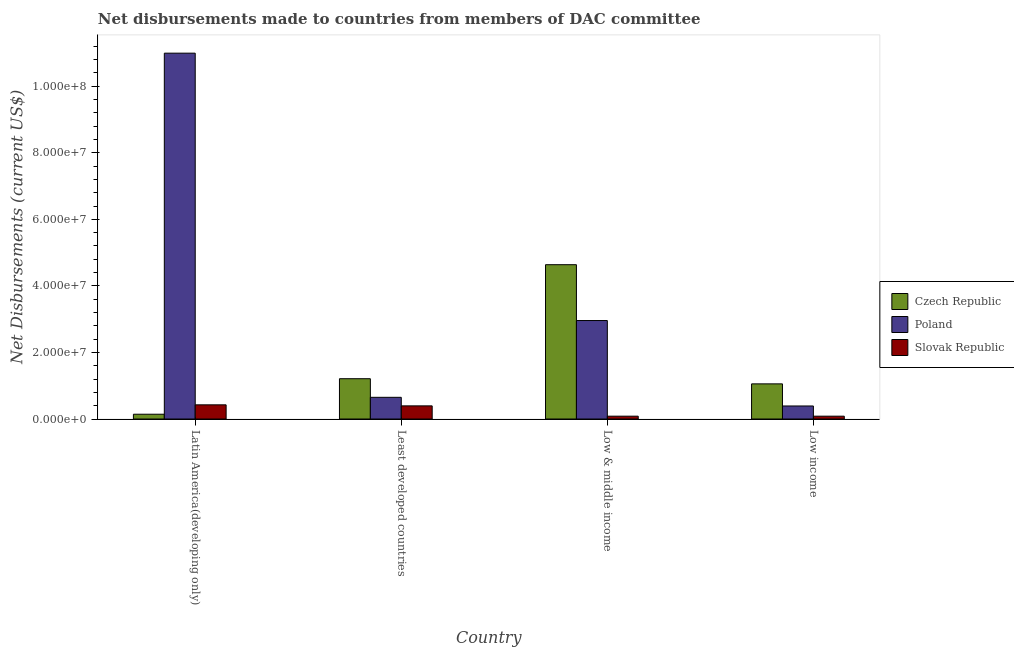How many different coloured bars are there?
Your answer should be very brief. 3. Are the number of bars per tick equal to the number of legend labels?
Your answer should be very brief. Yes. Are the number of bars on each tick of the X-axis equal?
Your answer should be compact. Yes. How many bars are there on the 3rd tick from the right?
Your answer should be very brief. 3. What is the label of the 2nd group of bars from the left?
Your answer should be very brief. Least developed countries. In how many cases, is the number of bars for a given country not equal to the number of legend labels?
Make the answer very short. 0. What is the net disbursements made by slovak republic in Least developed countries?
Keep it short and to the point. 3.95e+06. Across all countries, what is the maximum net disbursements made by czech republic?
Your answer should be compact. 4.64e+07. Across all countries, what is the minimum net disbursements made by slovak republic?
Make the answer very short. 8.50e+05. In which country was the net disbursements made by slovak republic maximum?
Make the answer very short. Latin America(developing only). In which country was the net disbursements made by czech republic minimum?
Make the answer very short. Latin America(developing only). What is the total net disbursements made by czech republic in the graph?
Your answer should be very brief. 7.05e+07. What is the difference between the net disbursements made by poland in Low & middle income and that in Low income?
Ensure brevity in your answer.  2.57e+07. What is the difference between the net disbursements made by slovak republic in Latin America(developing only) and the net disbursements made by poland in Low & middle income?
Your answer should be very brief. -2.53e+07. What is the average net disbursements made by poland per country?
Provide a short and direct response. 3.75e+07. What is the difference between the net disbursements made by slovak republic and net disbursements made by poland in Latin America(developing only)?
Your answer should be compact. -1.06e+08. In how many countries, is the net disbursements made by czech republic greater than 76000000 US$?
Ensure brevity in your answer.  0. What is the ratio of the net disbursements made by poland in Latin America(developing only) to that in Low income?
Your response must be concise. 28.04. Is the difference between the net disbursements made by poland in Latin America(developing only) and Least developed countries greater than the difference between the net disbursements made by slovak republic in Latin America(developing only) and Least developed countries?
Make the answer very short. Yes. What is the difference between the highest and the lowest net disbursements made by slovak republic?
Make the answer very short. 3.41e+06. In how many countries, is the net disbursements made by slovak republic greater than the average net disbursements made by slovak republic taken over all countries?
Your answer should be very brief. 2. What does the 1st bar from the left in Least developed countries represents?
Provide a short and direct response. Czech Republic. What does the 3rd bar from the right in Low income represents?
Your answer should be compact. Czech Republic. Is it the case that in every country, the sum of the net disbursements made by czech republic and net disbursements made by poland is greater than the net disbursements made by slovak republic?
Your answer should be compact. Yes. How many bars are there?
Your answer should be compact. 12. How many countries are there in the graph?
Keep it short and to the point. 4. What is the difference between two consecutive major ticks on the Y-axis?
Your answer should be compact. 2.00e+07. Are the values on the major ticks of Y-axis written in scientific E-notation?
Offer a very short reply. Yes. Where does the legend appear in the graph?
Ensure brevity in your answer.  Center right. How many legend labels are there?
Offer a terse response. 3. How are the legend labels stacked?
Make the answer very short. Vertical. What is the title of the graph?
Keep it short and to the point. Net disbursements made to countries from members of DAC committee. Does "Unemployment benefits" appear as one of the legend labels in the graph?
Ensure brevity in your answer.  No. What is the label or title of the Y-axis?
Provide a short and direct response. Net Disbursements (current US$). What is the Net Disbursements (current US$) of Czech Republic in Latin America(developing only)?
Provide a succinct answer. 1.44e+06. What is the Net Disbursements (current US$) in Poland in Latin America(developing only)?
Your answer should be very brief. 1.10e+08. What is the Net Disbursements (current US$) of Slovak Republic in Latin America(developing only)?
Your answer should be very brief. 4.26e+06. What is the Net Disbursements (current US$) of Czech Republic in Least developed countries?
Provide a succinct answer. 1.21e+07. What is the Net Disbursements (current US$) in Poland in Least developed countries?
Provide a succinct answer. 6.52e+06. What is the Net Disbursements (current US$) in Slovak Republic in Least developed countries?
Offer a very short reply. 3.95e+06. What is the Net Disbursements (current US$) of Czech Republic in Low & middle income?
Ensure brevity in your answer.  4.64e+07. What is the Net Disbursements (current US$) in Poland in Low & middle income?
Provide a short and direct response. 2.96e+07. What is the Net Disbursements (current US$) of Slovak Republic in Low & middle income?
Provide a short and direct response. 8.50e+05. What is the Net Disbursements (current US$) in Czech Republic in Low income?
Offer a terse response. 1.06e+07. What is the Net Disbursements (current US$) of Poland in Low income?
Your answer should be very brief. 3.92e+06. What is the Net Disbursements (current US$) in Slovak Republic in Low income?
Offer a terse response. 8.50e+05. Across all countries, what is the maximum Net Disbursements (current US$) of Czech Republic?
Provide a short and direct response. 4.64e+07. Across all countries, what is the maximum Net Disbursements (current US$) of Poland?
Provide a short and direct response. 1.10e+08. Across all countries, what is the maximum Net Disbursements (current US$) in Slovak Republic?
Give a very brief answer. 4.26e+06. Across all countries, what is the minimum Net Disbursements (current US$) of Czech Republic?
Keep it short and to the point. 1.44e+06. Across all countries, what is the minimum Net Disbursements (current US$) of Poland?
Offer a terse response. 3.92e+06. Across all countries, what is the minimum Net Disbursements (current US$) of Slovak Republic?
Your answer should be compact. 8.50e+05. What is the total Net Disbursements (current US$) in Czech Republic in the graph?
Offer a terse response. 7.05e+07. What is the total Net Disbursements (current US$) in Poland in the graph?
Give a very brief answer. 1.50e+08. What is the total Net Disbursements (current US$) in Slovak Republic in the graph?
Provide a short and direct response. 9.91e+06. What is the difference between the Net Disbursements (current US$) in Czech Republic in Latin America(developing only) and that in Least developed countries?
Your answer should be compact. -1.07e+07. What is the difference between the Net Disbursements (current US$) in Poland in Latin America(developing only) and that in Least developed countries?
Ensure brevity in your answer.  1.03e+08. What is the difference between the Net Disbursements (current US$) of Czech Republic in Latin America(developing only) and that in Low & middle income?
Ensure brevity in your answer.  -4.49e+07. What is the difference between the Net Disbursements (current US$) of Poland in Latin America(developing only) and that in Low & middle income?
Offer a very short reply. 8.03e+07. What is the difference between the Net Disbursements (current US$) in Slovak Republic in Latin America(developing only) and that in Low & middle income?
Give a very brief answer. 3.41e+06. What is the difference between the Net Disbursements (current US$) in Czech Republic in Latin America(developing only) and that in Low income?
Give a very brief answer. -9.12e+06. What is the difference between the Net Disbursements (current US$) of Poland in Latin America(developing only) and that in Low income?
Your answer should be compact. 1.06e+08. What is the difference between the Net Disbursements (current US$) in Slovak Republic in Latin America(developing only) and that in Low income?
Keep it short and to the point. 3.41e+06. What is the difference between the Net Disbursements (current US$) in Czech Republic in Least developed countries and that in Low & middle income?
Your response must be concise. -3.43e+07. What is the difference between the Net Disbursements (current US$) of Poland in Least developed countries and that in Low & middle income?
Offer a very short reply. -2.31e+07. What is the difference between the Net Disbursements (current US$) of Slovak Republic in Least developed countries and that in Low & middle income?
Your answer should be compact. 3.10e+06. What is the difference between the Net Disbursements (current US$) of Czech Republic in Least developed countries and that in Low income?
Your answer should be compact. 1.55e+06. What is the difference between the Net Disbursements (current US$) of Poland in Least developed countries and that in Low income?
Provide a succinct answer. 2.60e+06. What is the difference between the Net Disbursements (current US$) in Slovak Republic in Least developed countries and that in Low income?
Offer a terse response. 3.10e+06. What is the difference between the Net Disbursements (current US$) of Czech Republic in Low & middle income and that in Low income?
Make the answer very short. 3.58e+07. What is the difference between the Net Disbursements (current US$) in Poland in Low & middle income and that in Low income?
Offer a very short reply. 2.57e+07. What is the difference between the Net Disbursements (current US$) in Slovak Republic in Low & middle income and that in Low income?
Ensure brevity in your answer.  0. What is the difference between the Net Disbursements (current US$) of Czech Republic in Latin America(developing only) and the Net Disbursements (current US$) of Poland in Least developed countries?
Your answer should be compact. -5.08e+06. What is the difference between the Net Disbursements (current US$) in Czech Republic in Latin America(developing only) and the Net Disbursements (current US$) in Slovak Republic in Least developed countries?
Provide a succinct answer. -2.51e+06. What is the difference between the Net Disbursements (current US$) in Poland in Latin America(developing only) and the Net Disbursements (current US$) in Slovak Republic in Least developed countries?
Offer a terse response. 1.06e+08. What is the difference between the Net Disbursements (current US$) in Czech Republic in Latin America(developing only) and the Net Disbursements (current US$) in Poland in Low & middle income?
Give a very brief answer. -2.82e+07. What is the difference between the Net Disbursements (current US$) of Czech Republic in Latin America(developing only) and the Net Disbursements (current US$) of Slovak Republic in Low & middle income?
Your answer should be very brief. 5.90e+05. What is the difference between the Net Disbursements (current US$) of Poland in Latin America(developing only) and the Net Disbursements (current US$) of Slovak Republic in Low & middle income?
Your response must be concise. 1.09e+08. What is the difference between the Net Disbursements (current US$) of Czech Republic in Latin America(developing only) and the Net Disbursements (current US$) of Poland in Low income?
Provide a short and direct response. -2.48e+06. What is the difference between the Net Disbursements (current US$) in Czech Republic in Latin America(developing only) and the Net Disbursements (current US$) in Slovak Republic in Low income?
Make the answer very short. 5.90e+05. What is the difference between the Net Disbursements (current US$) of Poland in Latin America(developing only) and the Net Disbursements (current US$) of Slovak Republic in Low income?
Give a very brief answer. 1.09e+08. What is the difference between the Net Disbursements (current US$) in Czech Republic in Least developed countries and the Net Disbursements (current US$) in Poland in Low & middle income?
Ensure brevity in your answer.  -1.75e+07. What is the difference between the Net Disbursements (current US$) in Czech Republic in Least developed countries and the Net Disbursements (current US$) in Slovak Republic in Low & middle income?
Your answer should be compact. 1.13e+07. What is the difference between the Net Disbursements (current US$) in Poland in Least developed countries and the Net Disbursements (current US$) in Slovak Republic in Low & middle income?
Your answer should be very brief. 5.67e+06. What is the difference between the Net Disbursements (current US$) in Czech Republic in Least developed countries and the Net Disbursements (current US$) in Poland in Low income?
Keep it short and to the point. 8.19e+06. What is the difference between the Net Disbursements (current US$) in Czech Republic in Least developed countries and the Net Disbursements (current US$) in Slovak Republic in Low income?
Keep it short and to the point. 1.13e+07. What is the difference between the Net Disbursements (current US$) in Poland in Least developed countries and the Net Disbursements (current US$) in Slovak Republic in Low income?
Make the answer very short. 5.67e+06. What is the difference between the Net Disbursements (current US$) of Czech Republic in Low & middle income and the Net Disbursements (current US$) of Poland in Low income?
Provide a succinct answer. 4.24e+07. What is the difference between the Net Disbursements (current US$) in Czech Republic in Low & middle income and the Net Disbursements (current US$) in Slovak Republic in Low income?
Your answer should be compact. 4.55e+07. What is the difference between the Net Disbursements (current US$) in Poland in Low & middle income and the Net Disbursements (current US$) in Slovak Republic in Low income?
Your answer should be compact. 2.87e+07. What is the average Net Disbursements (current US$) of Czech Republic per country?
Provide a short and direct response. 1.76e+07. What is the average Net Disbursements (current US$) of Poland per country?
Your answer should be compact. 3.75e+07. What is the average Net Disbursements (current US$) of Slovak Republic per country?
Provide a succinct answer. 2.48e+06. What is the difference between the Net Disbursements (current US$) of Czech Republic and Net Disbursements (current US$) of Poland in Latin America(developing only)?
Your response must be concise. -1.08e+08. What is the difference between the Net Disbursements (current US$) of Czech Republic and Net Disbursements (current US$) of Slovak Republic in Latin America(developing only)?
Your answer should be very brief. -2.82e+06. What is the difference between the Net Disbursements (current US$) of Poland and Net Disbursements (current US$) of Slovak Republic in Latin America(developing only)?
Your answer should be compact. 1.06e+08. What is the difference between the Net Disbursements (current US$) of Czech Republic and Net Disbursements (current US$) of Poland in Least developed countries?
Offer a terse response. 5.59e+06. What is the difference between the Net Disbursements (current US$) of Czech Republic and Net Disbursements (current US$) of Slovak Republic in Least developed countries?
Ensure brevity in your answer.  8.16e+06. What is the difference between the Net Disbursements (current US$) of Poland and Net Disbursements (current US$) of Slovak Republic in Least developed countries?
Give a very brief answer. 2.57e+06. What is the difference between the Net Disbursements (current US$) in Czech Republic and Net Disbursements (current US$) in Poland in Low & middle income?
Offer a terse response. 1.68e+07. What is the difference between the Net Disbursements (current US$) in Czech Republic and Net Disbursements (current US$) in Slovak Republic in Low & middle income?
Ensure brevity in your answer.  4.55e+07. What is the difference between the Net Disbursements (current US$) in Poland and Net Disbursements (current US$) in Slovak Republic in Low & middle income?
Make the answer very short. 2.87e+07. What is the difference between the Net Disbursements (current US$) of Czech Republic and Net Disbursements (current US$) of Poland in Low income?
Provide a short and direct response. 6.64e+06. What is the difference between the Net Disbursements (current US$) of Czech Republic and Net Disbursements (current US$) of Slovak Republic in Low income?
Ensure brevity in your answer.  9.71e+06. What is the difference between the Net Disbursements (current US$) of Poland and Net Disbursements (current US$) of Slovak Republic in Low income?
Your answer should be compact. 3.07e+06. What is the ratio of the Net Disbursements (current US$) in Czech Republic in Latin America(developing only) to that in Least developed countries?
Ensure brevity in your answer.  0.12. What is the ratio of the Net Disbursements (current US$) in Poland in Latin America(developing only) to that in Least developed countries?
Provide a succinct answer. 16.86. What is the ratio of the Net Disbursements (current US$) in Slovak Republic in Latin America(developing only) to that in Least developed countries?
Give a very brief answer. 1.08. What is the ratio of the Net Disbursements (current US$) of Czech Republic in Latin America(developing only) to that in Low & middle income?
Make the answer very short. 0.03. What is the ratio of the Net Disbursements (current US$) in Poland in Latin America(developing only) to that in Low & middle income?
Your answer should be compact. 3.72. What is the ratio of the Net Disbursements (current US$) of Slovak Republic in Latin America(developing only) to that in Low & middle income?
Your answer should be very brief. 5.01. What is the ratio of the Net Disbursements (current US$) in Czech Republic in Latin America(developing only) to that in Low income?
Ensure brevity in your answer.  0.14. What is the ratio of the Net Disbursements (current US$) of Poland in Latin America(developing only) to that in Low income?
Give a very brief answer. 28.04. What is the ratio of the Net Disbursements (current US$) in Slovak Republic in Latin America(developing only) to that in Low income?
Provide a short and direct response. 5.01. What is the ratio of the Net Disbursements (current US$) in Czech Republic in Least developed countries to that in Low & middle income?
Your answer should be very brief. 0.26. What is the ratio of the Net Disbursements (current US$) in Poland in Least developed countries to that in Low & middle income?
Your response must be concise. 0.22. What is the ratio of the Net Disbursements (current US$) of Slovak Republic in Least developed countries to that in Low & middle income?
Make the answer very short. 4.65. What is the ratio of the Net Disbursements (current US$) in Czech Republic in Least developed countries to that in Low income?
Ensure brevity in your answer.  1.15. What is the ratio of the Net Disbursements (current US$) in Poland in Least developed countries to that in Low income?
Your answer should be compact. 1.66. What is the ratio of the Net Disbursements (current US$) of Slovak Republic in Least developed countries to that in Low income?
Offer a terse response. 4.65. What is the ratio of the Net Disbursements (current US$) in Czech Republic in Low & middle income to that in Low income?
Offer a very short reply. 4.39. What is the ratio of the Net Disbursements (current US$) of Poland in Low & middle income to that in Low income?
Your answer should be very brief. 7.55. What is the ratio of the Net Disbursements (current US$) in Slovak Republic in Low & middle income to that in Low income?
Offer a terse response. 1. What is the difference between the highest and the second highest Net Disbursements (current US$) in Czech Republic?
Your answer should be compact. 3.43e+07. What is the difference between the highest and the second highest Net Disbursements (current US$) of Poland?
Offer a terse response. 8.03e+07. What is the difference between the highest and the lowest Net Disbursements (current US$) of Czech Republic?
Your answer should be compact. 4.49e+07. What is the difference between the highest and the lowest Net Disbursements (current US$) of Poland?
Offer a very short reply. 1.06e+08. What is the difference between the highest and the lowest Net Disbursements (current US$) in Slovak Republic?
Provide a succinct answer. 3.41e+06. 